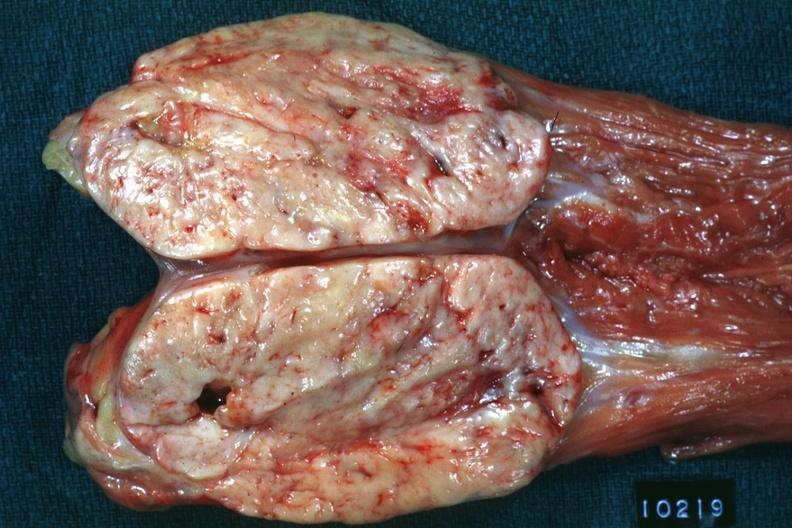does carcinomatosis psoa natural color large ovoid typical sarcoma?
Answer the question using a single word or phrase. No 